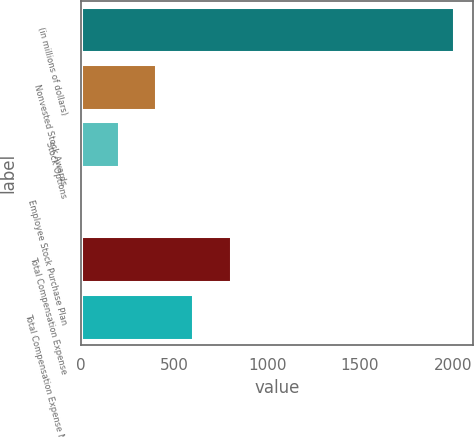<chart> <loc_0><loc_0><loc_500><loc_500><bar_chart><fcel>(in millions of dollars)<fcel>Nonvested Stock Awards<fcel>Stock Options<fcel>Employee Stock Purchase Plan<fcel>Total Compensation Expense<fcel>Total Compensation Expense Net<nl><fcel>2008<fcel>402.32<fcel>201.61<fcel>0.9<fcel>803.74<fcel>603.03<nl></chart> 